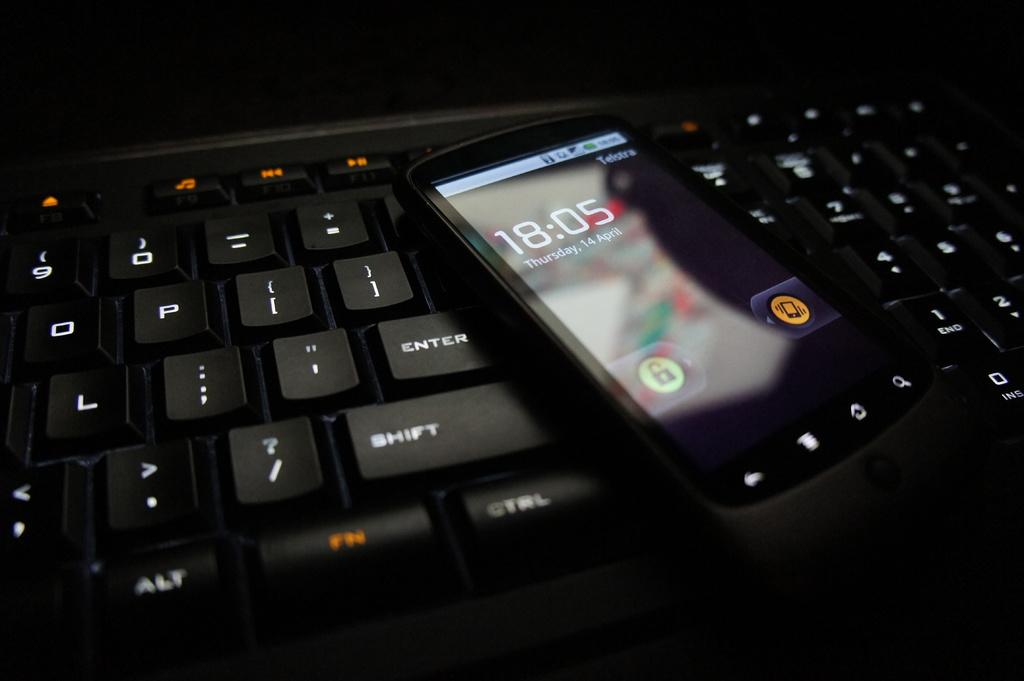Provide a one-sentence caption for the provided image. A black phone shows the time as 18:05 on Thursday the 14th of April. 